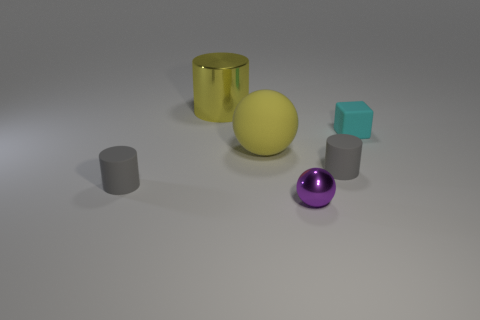What shape is the purple object that is the same size as the cyan rubber object?
Your response must be concise. Sphere. Is there a cyan rubber object of the same shape as the big yellow matte thing?
Make the answer very short. No. Is the number of small metallic cubes less than the number of big balls?
Keep it short and to the point. Yes. Does the gray thing that is to the left of the big yellow sphere have the same size as the ball that is behind the metal ball?
Keep it short and to the point. No. What number of things are either tiny gray matte cylinders or cyan metal balls?
Your response must be concise. 2. There is a yellow object behind the cyan object; what is its size?
Your response must be concise. Large. What number of cylinders are right of the tiny gray rubber thing that is to the right of the small cylinder that is on the left side of the purple metallic sphere?
Your answer should be compact. 0. Do the big ball and the metal cylinder have the same color?
Offer a terse response. Yes. How many shiny things are behind the purple shiny thing and in front of the tiny cyan matte cube?
Your response must be concise. 0. What shape is the matte thing that is to the left of the large shiny cylinder?
Your answer should be compact. Cylinder. 